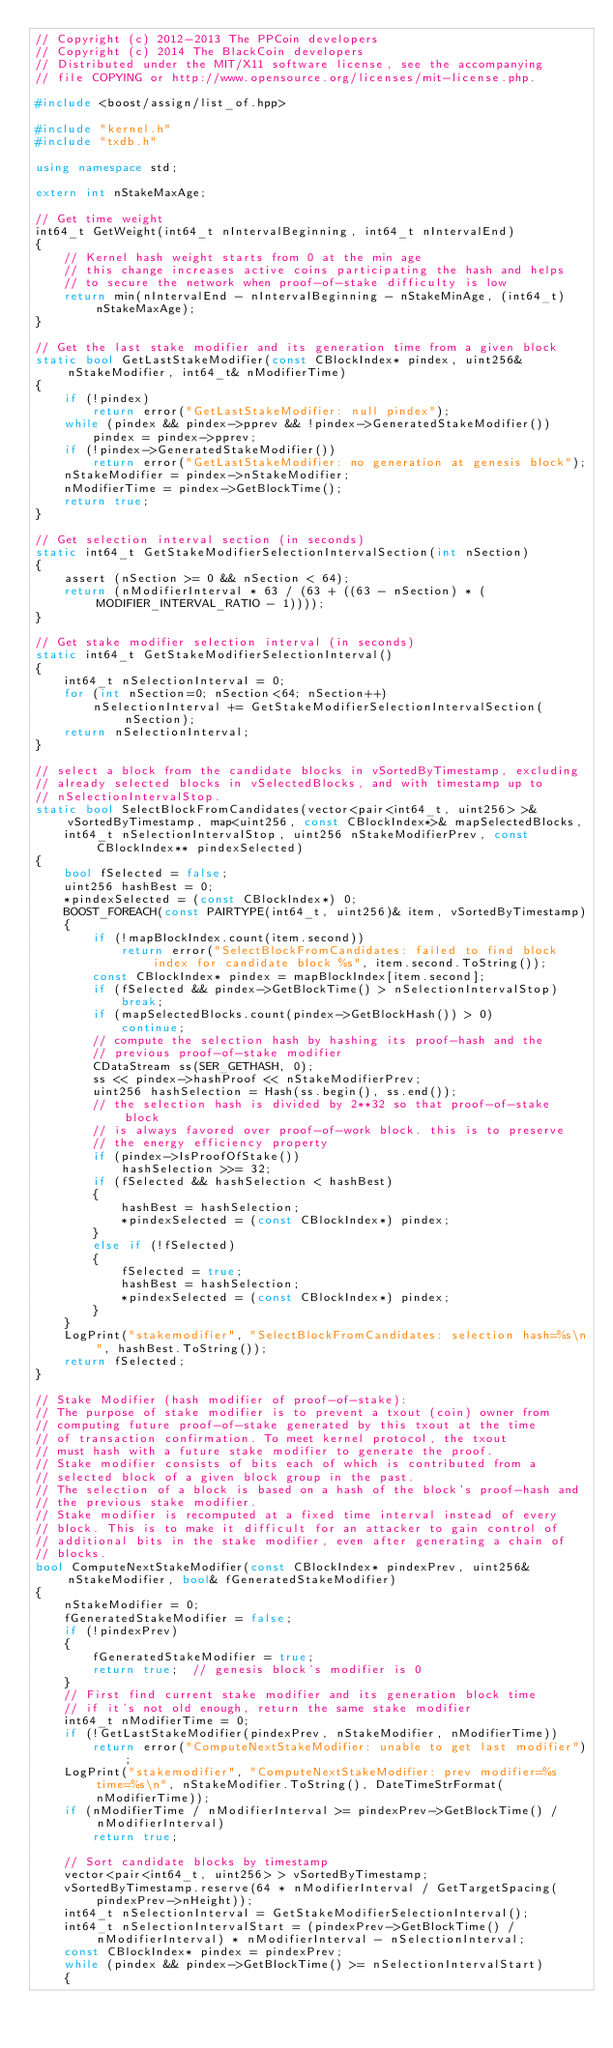Convert code to text. <code><loc_0><loc_0><loc_500><loc_500><_C++_>// Copyright (c) 2012-2013 The PPCoin developers
// Copyright (c) 2014 The BlackCoin developers
// Distributed under the MIT/X11 software license, see the accompanying
// file COPYING or http://www.opensource.org/licenses/mit-license.php.

#include <boost/assign/list_of.hpp>

#include "kernel.h"
#include "txdb.h"

using namespace std;

extern int nStakeMaxAge;

// Get time weight
int64_t GetWeight(int64_t nIntervalBeginning, int64_t nIntervalEnd)
{
    // Kernel hash weight starts from 0 at the min age
    // this change increases active coins participating the hash and helps
    // to secure the network when proof-of-stake difficulty is low
    return min(nIntervalEnd - nIntervalBeginning - nStakeMinAge, (int64_t)nStakeMaxAge);
}

// Get the last stake modifier and its generation time from a given block
static bool GetLastStakeModifier(const CBlockIndex* pindex, uint256& nStakeModifier, int64_t& nModifierTime)
{
    if (!pindex)
        return error("GetLastStakeModifier: null pindex");
    while (pindex && pindex->pprev && !pindex->GeneratedStakeModifier())
        pindex = pindex->pprev;
    if (!pindex->GeneratedStakeModifier())
        return error("GetLastStakeModifier: no generation at genesis block");
    nStakeModifier = pindex->nStakeModifier;
    nModifierTime = pindex->GetBlockTime();
    return true;
}

// Get selection interval section (in seconds)
static int64_t GetStakeModifierSelectionIntervalSection(int nSection)
{
    assert (nSection >= 0 && nSection < 64);
    return (nModifierInterval * 63 / (63 + ((63 - nSection) * (MODIFIER_INTERVAL_RATIO - 1))));
}

// Get stake modifier selection interval (in seconds)
static int64_t GetStakeModifierSelectionInterval()
{
    int64_t nSelectionInterval = 0;
    for (int nSection=0; nSection<64; nSection++)
        nSelectionInterval += GetStakeModifierSelectionIntervalSection(nSection);
    return nSelectionInterval;
}

// select a block from the candidate blocks in vSortedByTimestamp, excluding
// already selected blocks in vSelectedBlocks, and with timestamp up to
// nSelectionIntervalStop.
static bool SelectBlockFromCandidates(vector<pair<int64_t, uint256> >& vSortedByTimestamp, map<uint256, const CBlockIndex*>& mapSelectedBlocks,
    int64_t nSelectionIntervalStop, uint256 nStakeModifierPrev, const CBlockIndex** pindexSelected)
{
    bool fSelected = false;
    uint256 hashBest = 0;
    *pindexSelected = (const CBlockIndex*) 0;
    BOOST_FOREACH(const PAIRTYPE(int64_t, uint256)& item, vSortedByTimestamp)
    {
        if (!mapBlockIndex.count(item.second))
            return error("SelectBlockFromCandidates: failed to find block index for candidate block %s", item.second.ToString());
        const CBlockIndex* pindex = mapBlockIndex[item.second];
        if (fSelected && pindex->GetBlockTime() > nSelectionIntervalStop)
            break;
        if (mapSelectedBlocks.count(pindex->GetBlockHash()) > 0)
            continue;
        // compute the selection hash by hashing its proof-hash and the
        // previous proof-of-stake modifier
        CDataStream ss(SER_GETHASH, 0);
        ss << pindex->hashProof << nStakeModifierPrev;
        uint256 hashSelection = Hash(ss.begin(), ss.end());
        // the selection hash is divided by 2**32 so that proof-of-stake block
        // is always favored over proof-of-work block. this is to preserve
        // the energy efficiency property
        if (pindex->IsProofOfStake())
            hashSelection >>= 32;
        if (fSelected && hashSelection < hashBest)
        {
            hashBest = hashSelection;
            *pindexSelected = (const CBlockIndex*) pindex;
        }
        else if (!fSelected)
        {
            fSelected = true;
            hashBest = hashSelection;
            *pindexSelected = (const CBlockIndex*) pindex;
        }
    }
    LogPrint("stakemodifier", "SelectBlockFromCandidates: selection hash=%s\n", hashBest.ToString());
    return fSelected;
}

// Stake Modifier (hash modifier of proof-of-stake):
// The purpose of stake modifier is to prevent a txout (coin) owner from
// computing future proof-of-stake generated by this txout at the time
// of transaction confirmation. To meet kernel protocol, the txout
// must hash with a future stake modifier to generate the proof.
// Stake modifier consists of bits each of which is contributed from a
// selected block of a given block group in the past.
// The selection of a block is based on a hash of the block's proof-hash and
// the previous stake modifier.
// Stake modifier is recomputed at a fixed time interval instead of every
// block. This is to make it difficult for an attacker to gain control of
// additional bits in the stake modifier, even after generating a chain of
// blocks.
bool ComputeNextStakeModifier(const CBlockIndex* pindexPrev, uint256& nStakeModifier, bool& fGeneratedStakeModifier)
{
    nStakeModifier = 0;
    fGeneratedStakeModifier = false;
    if (!pindexPrev)
    {
        fGeneratedStakeModifier = true;
        return true;  // genesis block's modifier is 0
    }
    // First find current stake modifier and its generation block time
    // if it's not old enough, return the same stake modifier
    int64_t nModifierTime = 0;
    if (!GetLastStakeModifier(pindexPrev, nStakeModifier, nModifierTime))
        return error("ComputeNextStakeModifier: unable to get last modifier");
    LogPrint("stakemodifier", "ComputeNextStakeModifier: prev modifier=%s time=%s\n", nStakeModifier.ToString(), DateTimeStrFormat(nModifierTime));
    if (nModifierTime / nModifierInterval >= pindexPrev->GetBlockTime() / nModifierInterval)
        return true;

    // Sort candidate blocks by timestamp
    vector<pair<int64_t, uint256> > vSortedByTimestamp;
    vSortedByTimestamp.reserve(64 * nModifierInterval / GetTargetSpacing(pindexPrev->nHeight));
    int64_t nSelectionInterval = GetStakeModifierSelectionInterval();
    int64_t nSelectionIntervalStart = (pindexPrev->GetBlockTime() / nModifierInterval) * nModifierInterval - nSelectionInterval;
    const CBlockIndex* pindex = pindexPrev;
    while (pindex && pindex->GetBlockTime() >= nSelectionIntervalStart)
    {</code> 